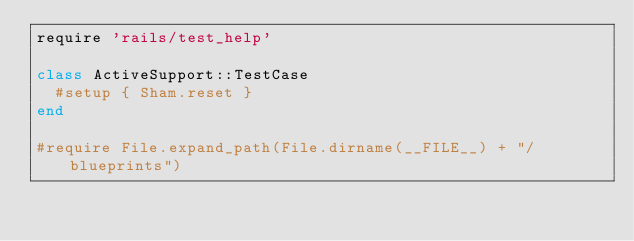Convert code to text. <code><loc_0><loc_0><loc_500><loc_500><_Ruby_>require 'rails/test_help'

class ActiveSupport::TestCase
  #setup { Sham.reset }
end

#require File.expand_path(File.dirname(__FILE__) + "/blueprints")
</code> 